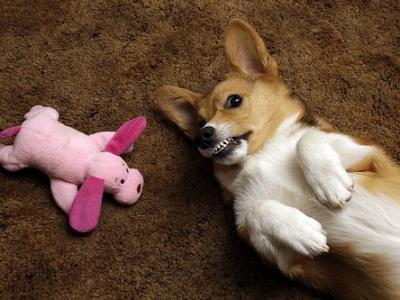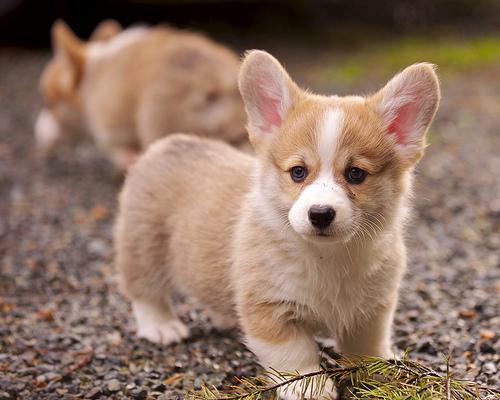The first image is the image on the left, the second image is the image on the right. Given the left and right images, does the statement "At least one image contains only one dog, which is standing on all fours and has its mouth closed." hold true? Answer yes or no. No. The first image is the image on the left, the second image is the image on the right. Considering the images on both sides, is "One of the dogs is near grass, but not actually IN grass." valid? Answer yes or no. No. 